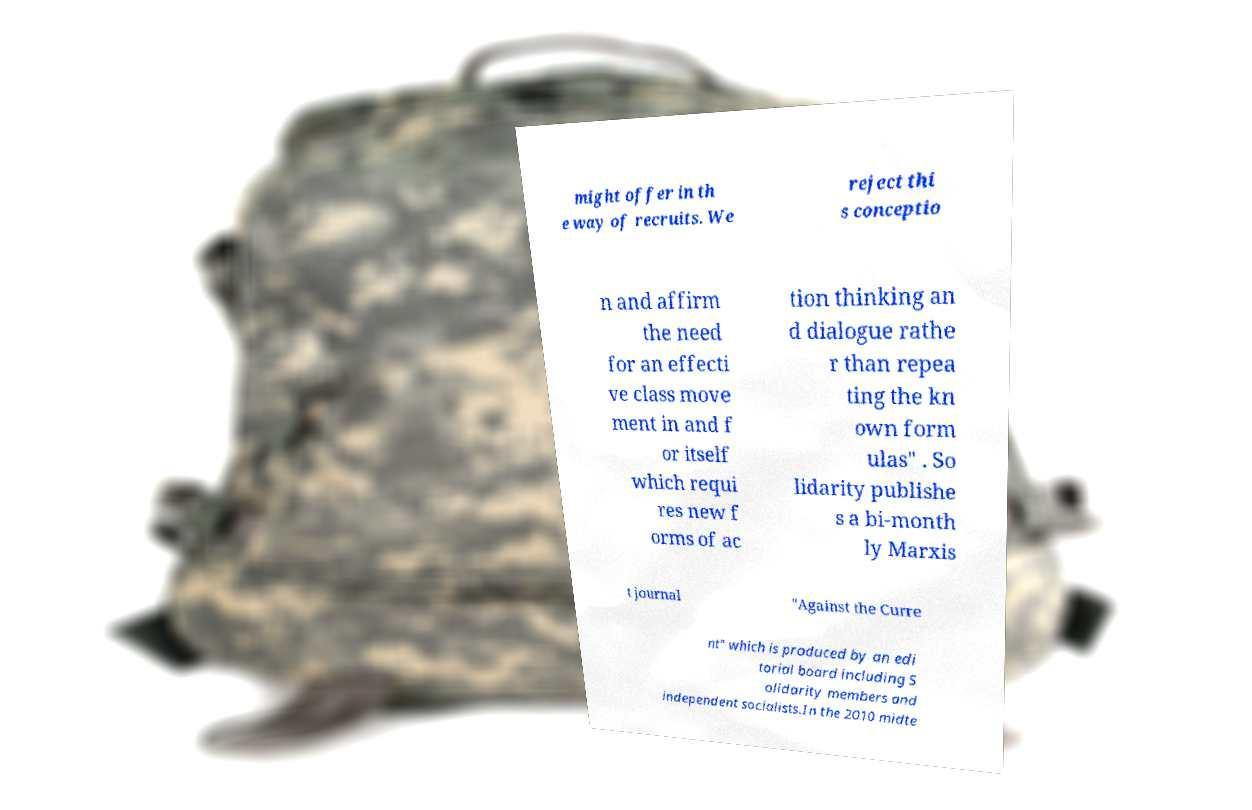I need the written content from this picture converted into text. Can you do that? might offer in th e way of recruits. We reject thi s conceptio n and affirm the need for an effecti ve class move ment in and f or itself which requi res new f orms of ac tion thinking an d dialogue rathe r than repea ting the kn own form ulas" . So lidarity publishe s a bi-month ly Marxis t journal "Against the Curre nt" which is produced by an edi torial board including S olidarity members and independent socialists.In the 2010 midte 